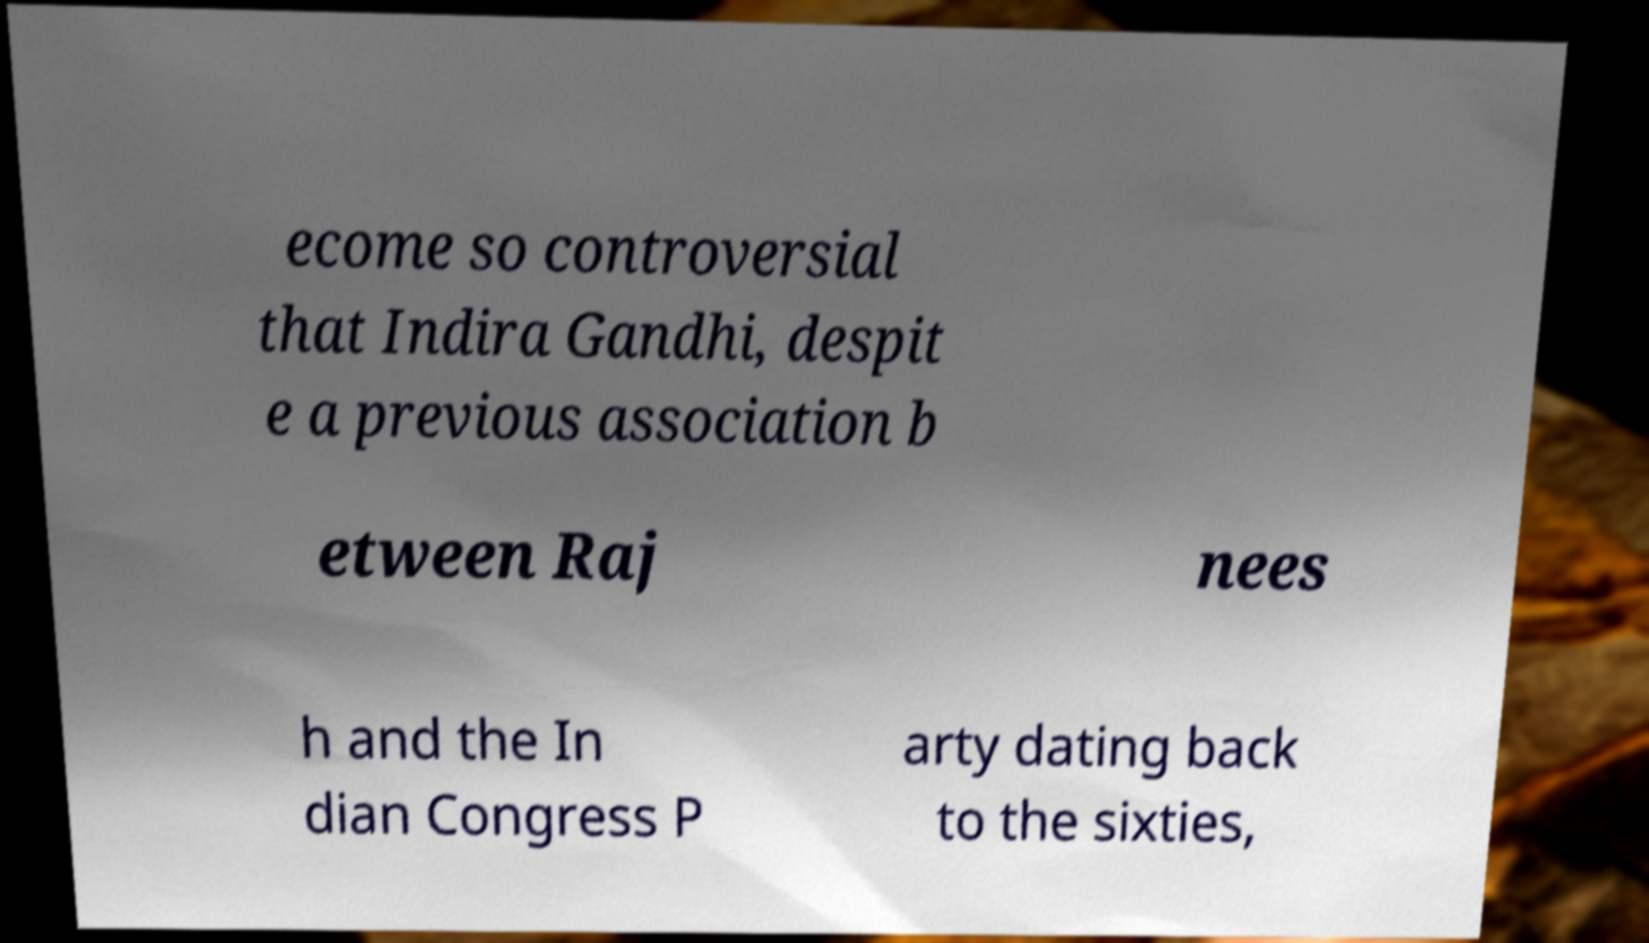Could you assist in decoding the text presented in this image and type it out clearly? ecome so controversial that Indira Gandhi, despit e a previous association b etween Raj nees h and the In dian Congress P arty dating back to the sixties, 